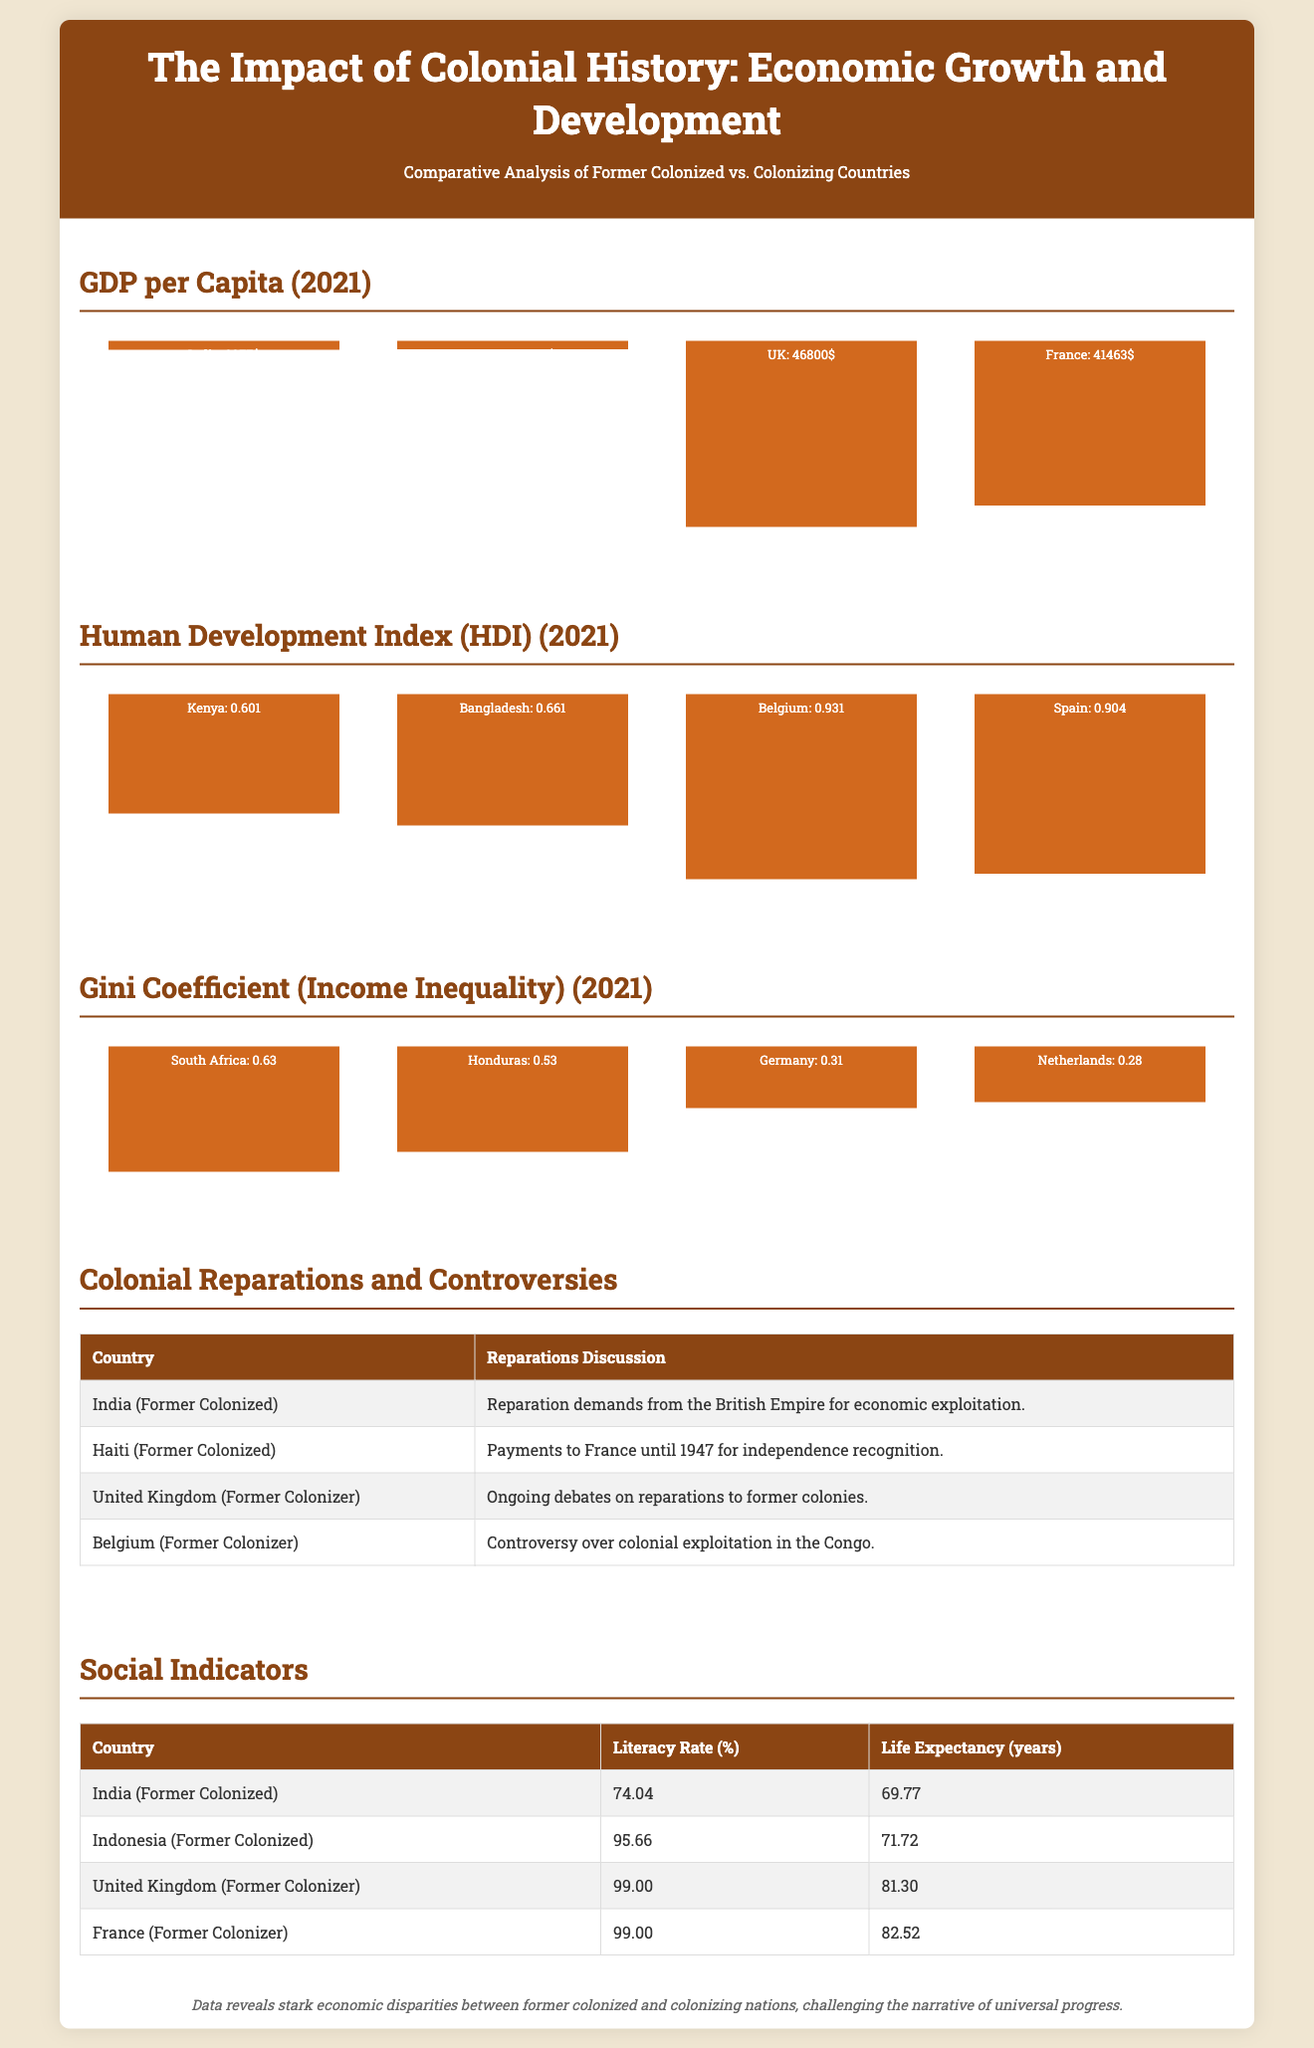What is the GDP per capita of India? The GDP per capita of India is listed in the document under the GDP per Capita section as $2277.
Answer: $2277 What is the Human Development Index (HDI) of Belgium? The HDI for Belgium is stated in the HDI section as 0.931.
Answer: 0.931 Which former colonized country has the highest literacy rate? The document lists literacy rates in the Social Indicators section, indicating that Indonesia has the highest rate at 95.66%.
Answer: 95.66% What is the Gini coefficient for Germany? The Gini coefficient for Germany is found in the Gini Coefficient section, where it is stated as 0.31.
Answer: 0.31 What reparation claim is mentioned for Haiti? The document references Haiti's reparation claims related to payments to France until 1947 for independence recognition in the Reparations section.
Answer: Payments to France until 1947 What country has the lowest life expectancy in the document? The Social Indicators section reveals that India has the lowest life expectancy listed at 69.77 years.
Answer: 69.77 years Which former colonizer is associated with colonial exploitation in the Congo? The document mentions Belgium in conjunction with controversies over colonial exploitation in the Congo in the Reparations section.
Answer: Belgium What is the GDP per capita of the United Kingdom? The GDP per capita of the United Kingdom is provided in the GDP per Capita section, noted as $46800.
Answer: $46800 